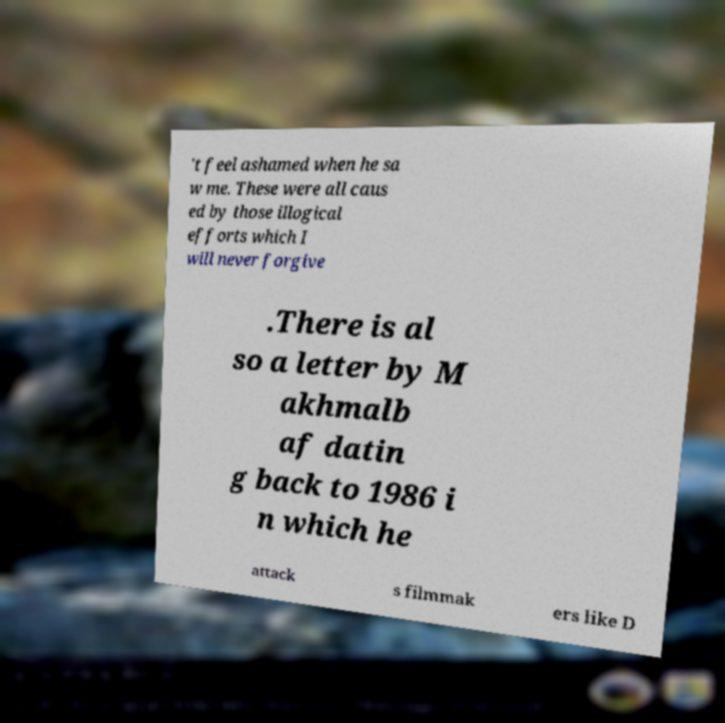Can you accurately transcribe the text from the provided image for me? 't feel ashamed when he sa w me. These were all caus ed by those illogical efforts which I will never forgive .There is al so a letter by M akhmalb af datin g back to 1986 i n which he attack s filmmak ers like D 